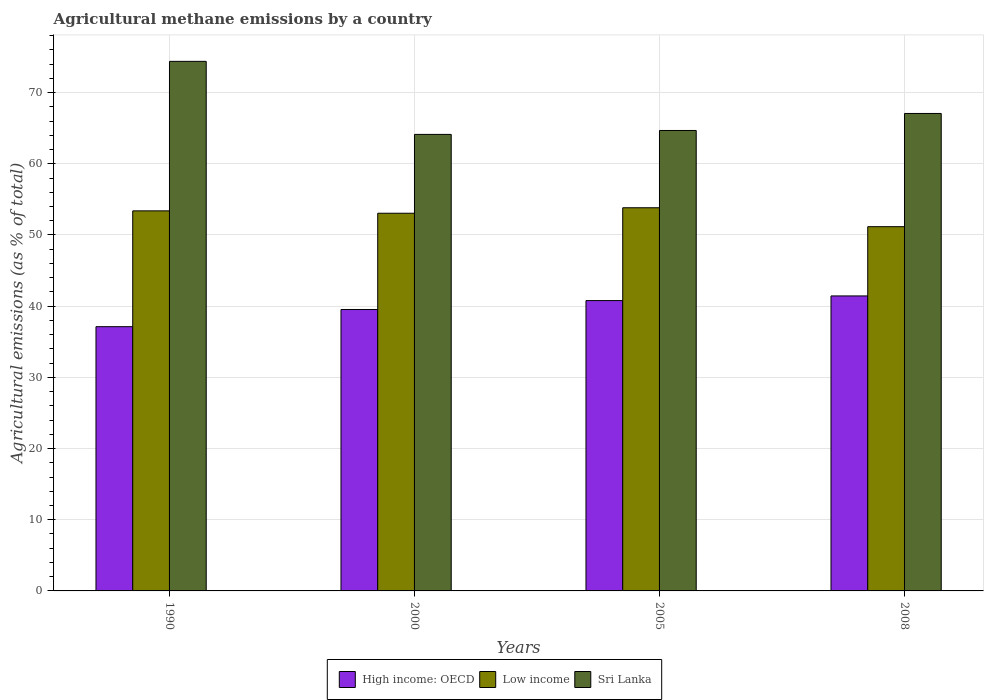How many groups of bars are there?
Offer a very short reply. 4. Are the number of bars per tick equal to the number of legend labels?
Provide a succinct answer. Yes. In how many cases, is the number of bars for a given year not equal to the number of legend labels?
Offer a terse response. 0. What is the amount of agricultural methane emitted in High income: OECD in 2005?
Provide a succinct answer. 40.78. Across all years, what is the maximum amount of agricultural methane emitted in Sri Lanka?
Provide a short and direct response. 74.39. Across all years, what is the minimum amount of agricultural methane emitted in Low income?
Offer a terse response. 51.17. In which year was the amount of agricultural methane emitted in High income: OECD maximum?
Provide a succinct answer. 2008. What is the total amount of agricultural methane emitted in Sri Lanka in the graph?
Give a very brief answer. 270.27. What is the difference between the amount of agricultural methane emitted in Low income in 2000 and that in 2008?
Give a very brief answer. 1.89. What is the difference between the amount of agricultural methane emitted in Low income in 2000 and the amount of agricultural methane emitted in Sri Lanka in 1990?
Offer a terse response. -21.34. What is the average amount of agricultural methane emitted in Sri Lanka per year?
Make the answer very short. 67.57. In the year 1990, what is the difference between the amount of agricultural methane emitted in High income: OECD and amount of agricultural methane emitted in Low income?
Give a very brief answer. -16.27. What is the ratio of the amount of agricultural methane emitted in High income: OECD in 2000 to that in 2005?
Your answer should be very brief. 0.97. What is the difference between the highest and the second highest amount of agricultural methane emitted in High income: OECD?
Keep it short and to the point. 0.65. What is the difference between the highest and the lowest amount of agricultural methane emitted in High income: OECD?
Your answer should be compact. 4.32. In how many years, is the amount of agricultural methane emitted in Sri Lanka greater than the average amount of agricultural methane emitted in Sri Lanka taken over all years?
Your answer should be very brief. 1. Is the sum of the amount of agricultural methane emitted in Sri Lanka in 1990 and 2005 greater than the maximum amount of agricultural methane emitted in Low income across all years?
Keep it short and to the point. Yes. What does the 1st bar from the left in 1990 represents?
Ensure brevity in your answer.  High income: OECD. What does the 1st bar from the right in 2005 represents?
Your answer should be very brief. Sri Lanka. Is it the case that in every year, the sum of the amount of agricultural methane emitted in Sri Lanka and amount of agricultural methane emitted in Low income is greater than the amount of agricultural methane emitted in High income: OECD?
Offer a very short reply. Yes. Are all the bars in the graph horizontal?
Your answer should be very brief. No. How many years are there in the graph?
Provide a succinct answer. 4. Are the values on the major ticks of Y-axis written in scientific E-notation?
Provide a short and direct response. No. What is the title of the graph?
Your answer should be very brief. Agricultural methane emissions by a country. Does "Switzerland" appear as one of the legend labels in the graph?
Give a very brief answer. No. What is the label or title of the X-axis?
Your answer should be compact. Years. What is the label or title of the Y-axis?
Offer a terse response. Agricultural emissions (as % of total). What is the Agricultural emissions (as % of total) of High income: OECD in 1990?
Keep it short and to the point. 37.12. What is the Agricultural emissions (as % of total) of Low income in 1990?
Ensure brevity in your answer.  53.39. What is the Agricultural emissions (as % of total) of Sri Lanka in 1990?
Offer a terse response. 74.39. What is the Agricultural emissions (as % of total) in High income: OECD in 2000?
Ensure brevity in your answer.  39.53. What is the Agricultural emissions (as % of total) in Low income in 2000?
Offer a very short reply. 53.05. What is the Agricultural emissions (as % of total) of Sri Lanka in 2000?
Keep it short and to the point. 64.13. What is the Agricultural emissions (as % of total) in High income: OECD in 2005?
Offer a very short reply. 40.78. What is the Agricultural emissions (as % of total) in Low income in 2005?
Keep it short and to the point. 53.82. What is the Agricultural emissions (as % of total) in Sri Lanka in 2005?
Offer a very short reply. 64.68. What is the Agricultural emissions (as % of total) in High income: OECD in 2008?
Your answer should be compact. 41.44. What is the Agricultural emissions (as % of total) in Low income in 2008?
Offer a terse response. 51.17. What is the Agricultural emissions (as % of total) of Sri Lanka in 2008?
Offer a terse response. 67.07. Across all years, what is the maximum Agricultural emissions (as % of total) of High income: OECD?
Ensure brevity in your answer.  41.44. Across all years, what is the maximum Agricultural emissions (as % of total) of Low income?
Offer a terse response. 53.82. Across all years, what is the maximum Agricultural emissions (as % of total) of Sri Lanka?
Your response must be concise. 74.39. Across all years, what is the minimum Agricultural emissions (as % of total) of High income: OECD?
Your answer should be very brief. 37.12. Across all years, what is the minimum Agricultural emissions (as % of total) in Low income?
Make the answer very short. 51.17. Across all years, what is the minimum Agricultural emissions (as % of total) in Sri Lanka?
Make the answer very short. 64.13. What is the total Agricultural emissions (as % of total) in High income: OECD in the graph?
Provide a short and direct response. 158.87. What is the total Agricultural emissions (as % of total) in Low income in the graph?
Provide a succinct answer. 211.43. What is the total Agricultural emissions (as % of total) of Sri Lanka in the graph?
Keep it short and to the point. 270.27. What is the difference between the Agricultural emissions (as % of total) in High income: OECD in 1990 and that in 2000?
Give a very brief answer. -2.42. What is the difference between the Agricultural emissions (as % of total) in Low income in 1990 and that in 2000?
Ensure brevity in your answer.  0.33. What is the difference between the Agricultural emissions (as % of total) of Sri Lanka in 1990 and that in 2000?
Make the answer very short. 10.26. What is the difference between the Agricultural emissions (as % of total) of High income: OECD in 1990 and that in 2005?
Your response must be concise. -3.67. What is the difference between the Agricultural emissions (as % of total) of Low income in 1990 and that in 2005?
Ensure brevity in your answer.  -0.44. What is the difference between the Agricultural emissions (as % of total) of Sri Lanka in 1990 and that in 2005?
Provide a short and direct response. 9.71. What is the difference between the Agricultural emissions (as % of total) of High income: OECD in 1990 and that in 2008?
Offer a very short reply. -4.32. What is the difference between the Agricultural emissions (as % of total) in Low income in 1990 and that in 2008?
Your answer should be very brief. 2.22. What is the difference between the Agricultural emissions (as % of total) in Sri Lanka in 1990 and that in 2008?
Your answer should be compact. 7.32. What is the difference between the Agricultural emissions (as % of total) of High income: OECD in 2000 and that in 2005?
Provide a succinct answer. -1.25. What is the difference between the Agricultural emissions (as % of total) of Low income in 2000 and that in 2005?
Provide a succinct answer. -0.77. What is the difference between the Agricultural emissions (as % of total) in Sri Lanka in 2000 and that in 2005?
Your answer should be compact. -0.55. What is the difference between the Agricultural emissions (as % of total) of High income: OECD in 2000 and that in 2008?
Give a very brief answer. -1.9. What is the difference between the Agricultural emissions (as % of total) of Low income in 2000 and that in 2008?
Provide a short and direct response. 1.89. What is the difference between the Agricultural emissions (as % of total) of Sri Lanka in 2000 and that in 2008?
Provide a short and direct response. -2.94. What is the difference between the Agricultural emissions (as % of total) in High income: OECD in 2005 and that in 2008?
Your answer should be very brief. -0.65. What is the difference between the Agricultural emissions (as % of total) of Low income in 2005 and that in 2008?
Make the answer very short. 2.66. What is the difference between the Agricultural emissions (as % of total) of Sri Lanka in 2005 and that in 2008?
Your answer should be compact. -2.39. What is the difference between the Agricultural emissions (as % of total) in High income: OECD in 1990 and the Agricultural emissions (as % of total) in Low income in 2000?
Ensure brevity in your answer.  -15.94. What is the difference between the Agricultural emissions (as % of total) in High income: OECD in 1990 and the Agricultural emissions (as % of total) in Sri Lanka in 2000?
Keep it short and to the point. -27.01. What is the difference between the Agricultural emissions (as % of total) in Low income in 1990 and the Agricultural emissions (as % of total) in Sri Lanka in 2000?
Ensure brevity in your answer.  -10.74. What is the difference between the Agricultural emissions (as % of total) of High income: OECD in 1990 and the Agricultural emissions (as % of total) of Low income in 2005?
Your answer should be compact. -16.71. What is the difference between the Agricultural emissions (as % of total) of High income: OECD in 1990 and the Agricultural emissions (as % of total) of Sri Lanka in 2005?
Keep it short and to the point. -27.56. What is the difference between the Agricultural emissions (as % of total) of Low income in 1990 and the Agricultural emissions (as % of total) of Sri Lanka in 2005?
Offer a terse response. -11.29. What is the difference between the Agricultural emissions (as % of total) of High income: OECD in 1990 and the Agricultural emissions (as % of total) of Low income in 2008?
Your answer should be very brief. -14.05. What is the difference between the Agricultural emissions (as % of total) of High income: OECD in 1990 and the Agricultural emissions (as % of total) of Sri Lanka in 2008?
Offer a terse response. -29.95. What is the difference between the Agricultural emissions (as % of total) in Low income in 1990 and the Agricultural emissions (as % of total) in Sri Lanka in 2008?
Offer a very short reply. -13.68. What is the difference between the Agricultural emissions (as % of total) of High income: OECD in 2000 and the Agricultural emissions (as % of total) of Low income in 2005?
Ensure brevity in your answer.  -14.29. What is the difference between the Agricultural emissions (as % of total) of High income: OECD in 2000 and the Agricultural emissions (as % of total) of Sri Lanka in 2005?
Keep it short and to the point. -25.15. What is the difference between the Agricultural emissions (as % of total) in Low income in 2000 and the Agricultural emissions (as % of total) in Sri Lanka in 2005?
Provide a short and direct response. -11.62. What is the difference between the Agricultural emissions (as % of total) of High income: OECD in 2000 and the Agricultural emissions (as % of total) of Low income in 2008?
Keep it short and to the point. -11.63. What is the difference between the Agricultural emissions (as % of total) in High income: OECD in 2000 and the Agricultural emissions (as % of total) in Sri Lanka in 2008?
Offer a terse response. -27.54. What is the difference between the Agricultural emissions (as % of total) of Low income in 2000 and the Agricultural emissions (as % of total) of Sri Lanka in 2008?
Your answer should be compact. -14.01. What is the difference between the Agricultural emissions (as % of total) of High income: OECD in 2005 and the Agricultural emissions (as % of total) of Low income in 2008?
Give a very brief answer. -10.38. What is the difference between the Agricultural emissions (as % of total) in High income: OECD in 2005 and the Agricultural emissions (as % of total) in Sri Lanka in 2008?
Your answer should be very brief. -26.29. What is the difference between the Agricultural emissions (as % of total) of Low income in 2005 and the Agricultural emissions (as % of total) of Sri Lanka in 2008?
Your answer should be compact. -13.25. What is the average Agricultural emissions (as % of total) in High income: OECD per year?
Provide a short and direct response. 39.72. What is the average Agricultural emissions (as % of total) in Low income per year?
Give a very brief answer. 52.86. What is the average Agricultural emissions (as % of total) of Sri Lanka per year?
Your answer should be very brief. 67.57. In the year 1990, what is the difference between the Agricultural emissions (as % of total) of High income: OECD and Agricultural emissions (as % of total) of Low income?
Keep it short and to the point. -16.27. In the year 1990, what is the difference between the Agricultural emissions (as % of total) in High income: OECD and Agricultural emissions (as % of total) in Sri Lanka?
Offer a terse response. -37.27. In the year 1990, what is the difference between the Agricultural emissions (as % of total) of Low income and Agricultural emissions (as % of total) of Sri Lanka?
Give a very brief answer. -21. In the year 2000, what is the difference between the Agricultural emissions (as % of total) of High income: OECD and Agricultural emissions (as % of total) of Low income?
Offer a very short reply. -13.52. In the year 2000, what is the difference between the Agricultural emissions (as % of total) in High income: OECD and Agricultural emissions (as % of total) in Sri Lanka?
Your answer should be very brief. -24.59. In the year 2000, what is the difference between the Agricultural emissions (as % of total) of Low income and Agricultural emissions (as % of total) of Sri Lanka?
Give a very brief answer. -11.07. In the year 2005, what is the difference between the Agricultural emissions (as % of total) of High income: OECD and Agricultural emissions (as % of total) of Low income?
Your answer should be very brief. -13.04. In the year 2005, what is the difference between the Agricultural emissions (as % of total) in High income: OECD and Agricultural emissions (as % of total) in Sri Lanka?
Your response must be concise. -23.89. In the year 2005, what is the difference between the Agricultural emissions (as % of total) of Low income and Agricultural emissions (as % of total) of Sri Lanka?
Your answer should be very brief. -10.86. In the year 2008, what is the difference between the Agricultural emissions (as % of total) in High income: OECD and Agricultural emissions (as % of total) in Low income?
Give a very brief answer. -9.73. In the year 2008, what is the difference between the Agricultural emissions (as % of total) in High income: OECD and Agricultural emissions (as % of total) in Sri Lanka?
Make the answer very short. -25.63. In the year 2008, what is the difference between the Agricultural emissions (as % of total) in Low income and Agricultural emissions (as % of total) in Sri Lanka?
Offer a very short reply. -15.9. What is the ratio of the Agricultural emissions (as % of total) of High income: OECD in 1990 to that in 2000?
Ensure brevity in your answer.  0.94. What is the ratio of the Agricultural emissions (as % of total) in Low income in 1990 to that in 2000?
Keep it short and to the point. 1.01. What is the ratio of the Agricultural emissions (as % of total) of Sri Lanka in 1990 to that in 2000?
Make the answer very short. 1.16. What is the ratio of the Agricultural emissions (as % of total) of High income: OECD in 1990 to that in 2005?
Provide a succinct answer. 0.91. What is the ratio of the Agricultural emissions (as % of total) of Low income in 1990 to that in 2005?
Your answer should be compact. 0.99. What is the ratio of the Agricultural emissions (as % of total) of Sri Lanka in 1990 to that in 2005?
Make the answer very short. 1.15. What is the ratio of the Agricultural emissions (as % of total) of High income: OECD in 1990 to that in 2008?
Your response must be concise. 0.9. What is the ratio of the Agricultural emissions (as % of total) in Low income in 1990 to that in 2008?
Provide a succinct answer. 1.04. What is the ratio of the Agricultural emissions (as % of total) in Sri Lanka in 1990 to that in 2008?
Your response must be concise. 1.11. What is the ratio of the Agricultural emissions (as % of total) in High income: OECD in 2000 to that in 2005?
Ensure brevity in your answer.  0.97. What is the ratio of the Agricultural emissions (as % of total) of Low income in 2000 to that in 2005?
Your answer should be very brief. 0.99. What is the ratio of the Agricultural emissions (as % of total) of High income: OECD in 2000 to that in 2008?
Offer a very short reply. 0.95. What is the ratio of the Agricultural emissions (as % of total) in Low income in 2000 to that in 2008?
Make the answer very short. 1.04. What is the ratio of the Agricultural emissions (as % of total) of Sri Lanka in 2000 to that in 2008?
Your response must be concise. 0.96. What is the ratio of the Agricultural emissions (as % of total) in High income: OECD in 2005 to that in 2008?
Provide a short and direct response. 0.98. What is the ratio of the Agricultural emissions (as % of total) of Low income in 2005 to that in 2008?
Give a very brief answer. 1.05. What is the ratio of the Agricultural emissions (as % of total) in Sri Lanka in 2005 to that in 2008?
Ensure brevity in your answer.  0.96. What is the difference between the highest and the second highest Agricultural emissions (as % of total) in High income: OECD?
Your answer should be very brief. 0.65. What is the difference between the highest and the second highest Agricultural emissions (as % of total) in Low income?
Your answer should be compact. 0.44. What is the difference between the highest and the second highest Agricultural emissions (as % of total) of Sri Lanka?
Your response must be concise. 7.32. What is the difference between the highest and the lowest Agricultural emissions (as % of total) of High income: OECD?
Keep it short and to the point. 4.32. What is the difference between the highest and the lowest Agricultural emissions (as % of total) of Low income?
Keep it short and to the point. 2.66. What is the difference between the highest and the lowest Agricultural emissions (as % of total) of Sri Lanka?
Keep it short and to the point. 10.26. 